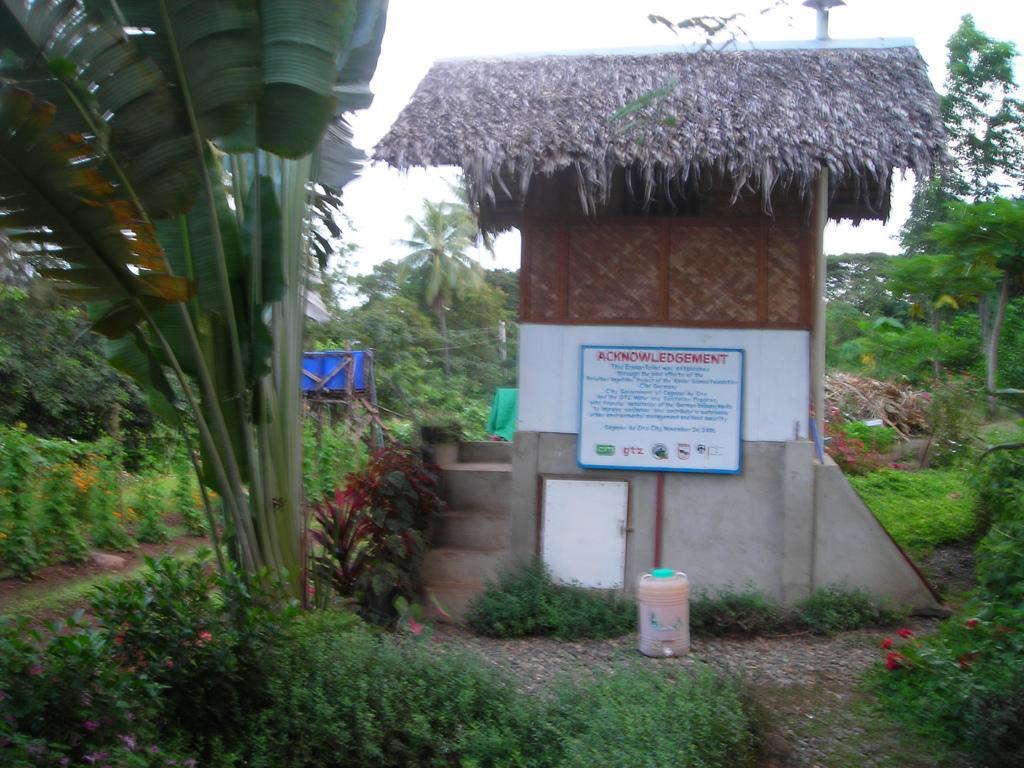Please provide a concise description of this image. In this image I can see few trees and plants in green color. In front I can see a house in brown color and a board which is in white color attached to pole, background the sky is in white color. 